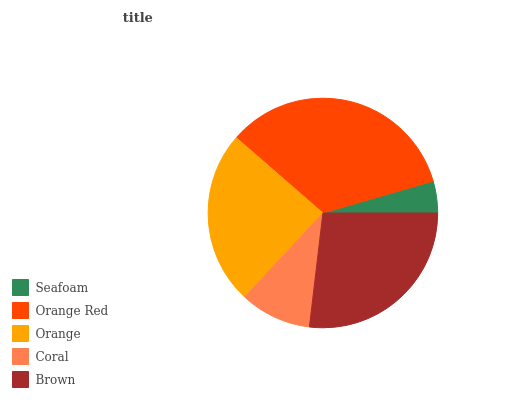Is Seafoam the minimum?
Answer yes or no. Yes. Is Orange Red the maximum?
Answer yes or no. Yes. Is Orange the minimum?
Answer yes or no. No. Is Orange the maximum?
Answer yes or no. No. Is Orange Red greater than Orange?
Answer yes or no. Yes. Is Orange less than Orange Red?
Answer yes or no. Yes. Is Orange greater than Orange Red?
Answer yes or no. No. Is Orange Red less than Orange?
Answer yes or no. No. Is Orange the high median?
Answer yes or no. Yes. Is Orange the low median?
Answer yes or no. Yes. Is Coral the high median?
Answer yes or no. No. Is Brown the low median?
Answer yes or no. No. 